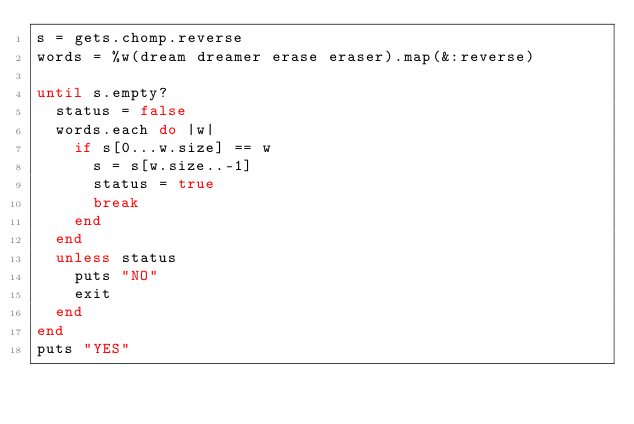Convert code to text. <code><loc_0><loc_0><loc_500><loc_500><_Ruby_>s = gets.chomp.reverse
words = %w(dream dreamer erase eraser).map(&:reverse)

until s.empty?
  status = false
  words.each do |w|
    if s[0...w.size] == w
      s = s[w.size..-1]
      status = true
      break
    end
  end
  unless status
    puts "NO"
    exit
  end
end
puts "YES"
</code> 